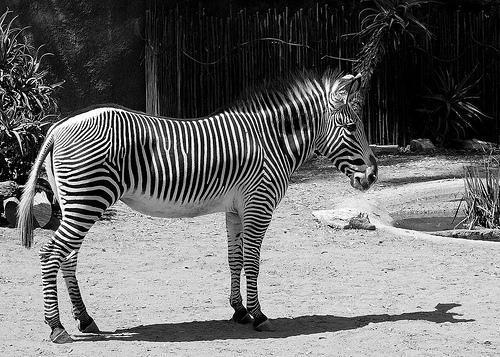How many zebrs are pictured?
Give a very brief answer. 1. 